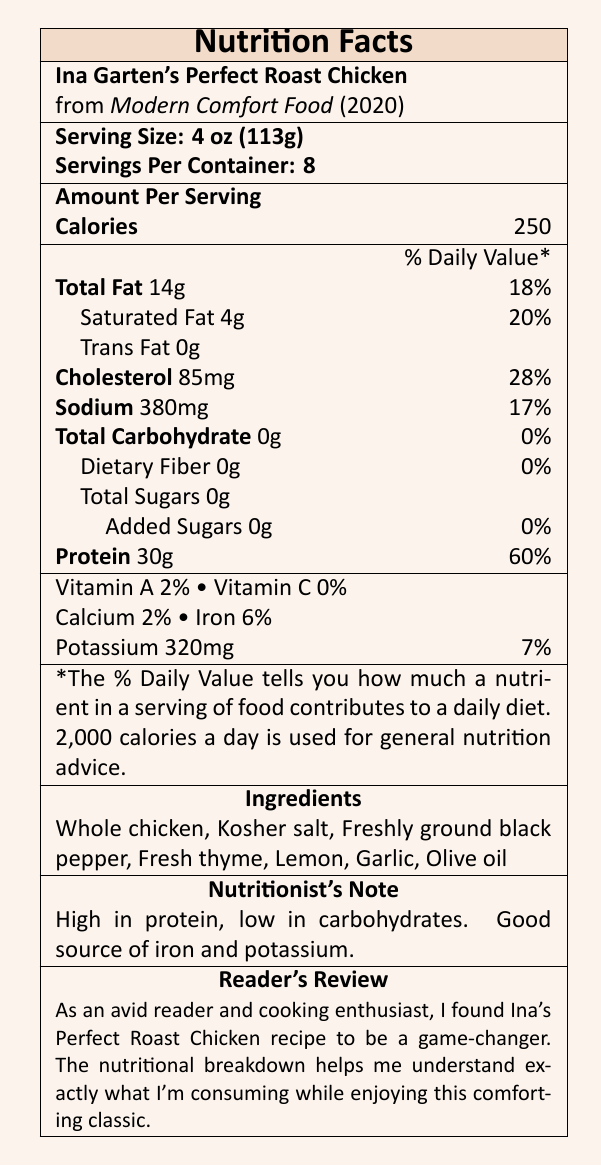what is the serving size? The document states that the serving size for the Perfect Roast Chicken is 4 oz (113g).
Answer: 4 oz (113g) how many servings per container? The document indicates there are 8 servings per container of the Perfect Roast Chicken.
Answer: 8 servings what is the amount of protein per serving? The document lists that each serving contains 30 grams of protein.
Answer: 30 grams how much cholesterol is in each serving? The document specifies that each serving of the Perfect Roast Chicken contains 85 mg of cholesterol.
Answer: 85 mg what is the total fat content per serving? The document shows that there are 14 grams of total fat per serving.
Answer: 14 grams how long does the preparation take? The document mentions that the preparation time for the Perfect Roast Chicken is 15 minutes.
Answer: 15 minutes what ingredients are used in the recipe? According to the document, the ingredients include whole chicken, kosher salt, freshly ground black pepper, fresh thyme, lemon, garlic, and olive oil.
Answer: Whole chicken, Kosher salt, Freshly ground black pepper, Fresh thyme, Lemon, Garlic, Olive oil which vitamin has the highest percentage of the daily value? A. Vitamin A B. Vitamin C C. Calcium D. Iron The document lists Iron as having a 6% daily value, the highest among the vitamins and minerals mentioned.
Answer: D. Iron how much sodium is in one serving? The document shows that there are 380 mg of sodium per serving.
Answer: 380 mg which best describes the flavor profile of the dish? A. Spicy B. Sweet C. Earthy D. Herb-infused, lemony, and savory The document describes the flavor profile as herb-infused, lemony, and savory.
Answer: D. Herb-infused, lemony, and savory is the perfect roast chicken low in carbohydrates? The document states that the dish is low in carbohydrates as it contains 0 grams of total carbohydrates.
Answer: Yes how much potassium is in one serving? The document states that each serving contains 320 mg of potassium.
Answer: 320 mg explain the nutritional benefits of the perfect roast chicken in the cookbook. The document's nutritionist note emphasizes that the Perfect Roast Chicken is high in protein and low in carbohydrates, making it a good source of iron and potassium.
Answer: High in protein, low in carbohydrates. Good source of iron and potassium. describe the document in your own words. The document provides all the necessary nutritional and preparatory information regarding Ina Garten's signature dish, highlighting its composition and health attributes for readers.
Answer: The document is a nutrition facts label for Ina Garten's Perfect Roast Chicken from her cookbook "Modern Comfort Food" (2020). It includes serving size, servings per container, and detailed nutritional information like calories, fat, cholesterol, sodium, carbohydrates, and protein. It lists ingredients, the cooking method, preparation and cooking times, flavor profile, and suggestions for food pairing. There are also comments on health benefits and sustainability. what year was the cookbook "Modern Comfort Food" published? The document states that "Modern Comfort Food" was published in 2020.
Answer: 2020 do the nutritional facts provide information about vitamins? The document provides information about the amounts of Vitamin A and Vitamin C.
Answer: Yes what is the exact page number where the Perfect Roast Chicken recipe can be found in the cookbook? The document indicates that the recipe can be found on page 126 of the cookbook.
Answer: 126 can you determine the price of the cookbook from the nutrition facts label? The document does not provide any information about the price of the cookbook.
Answer: Cannot be determined 